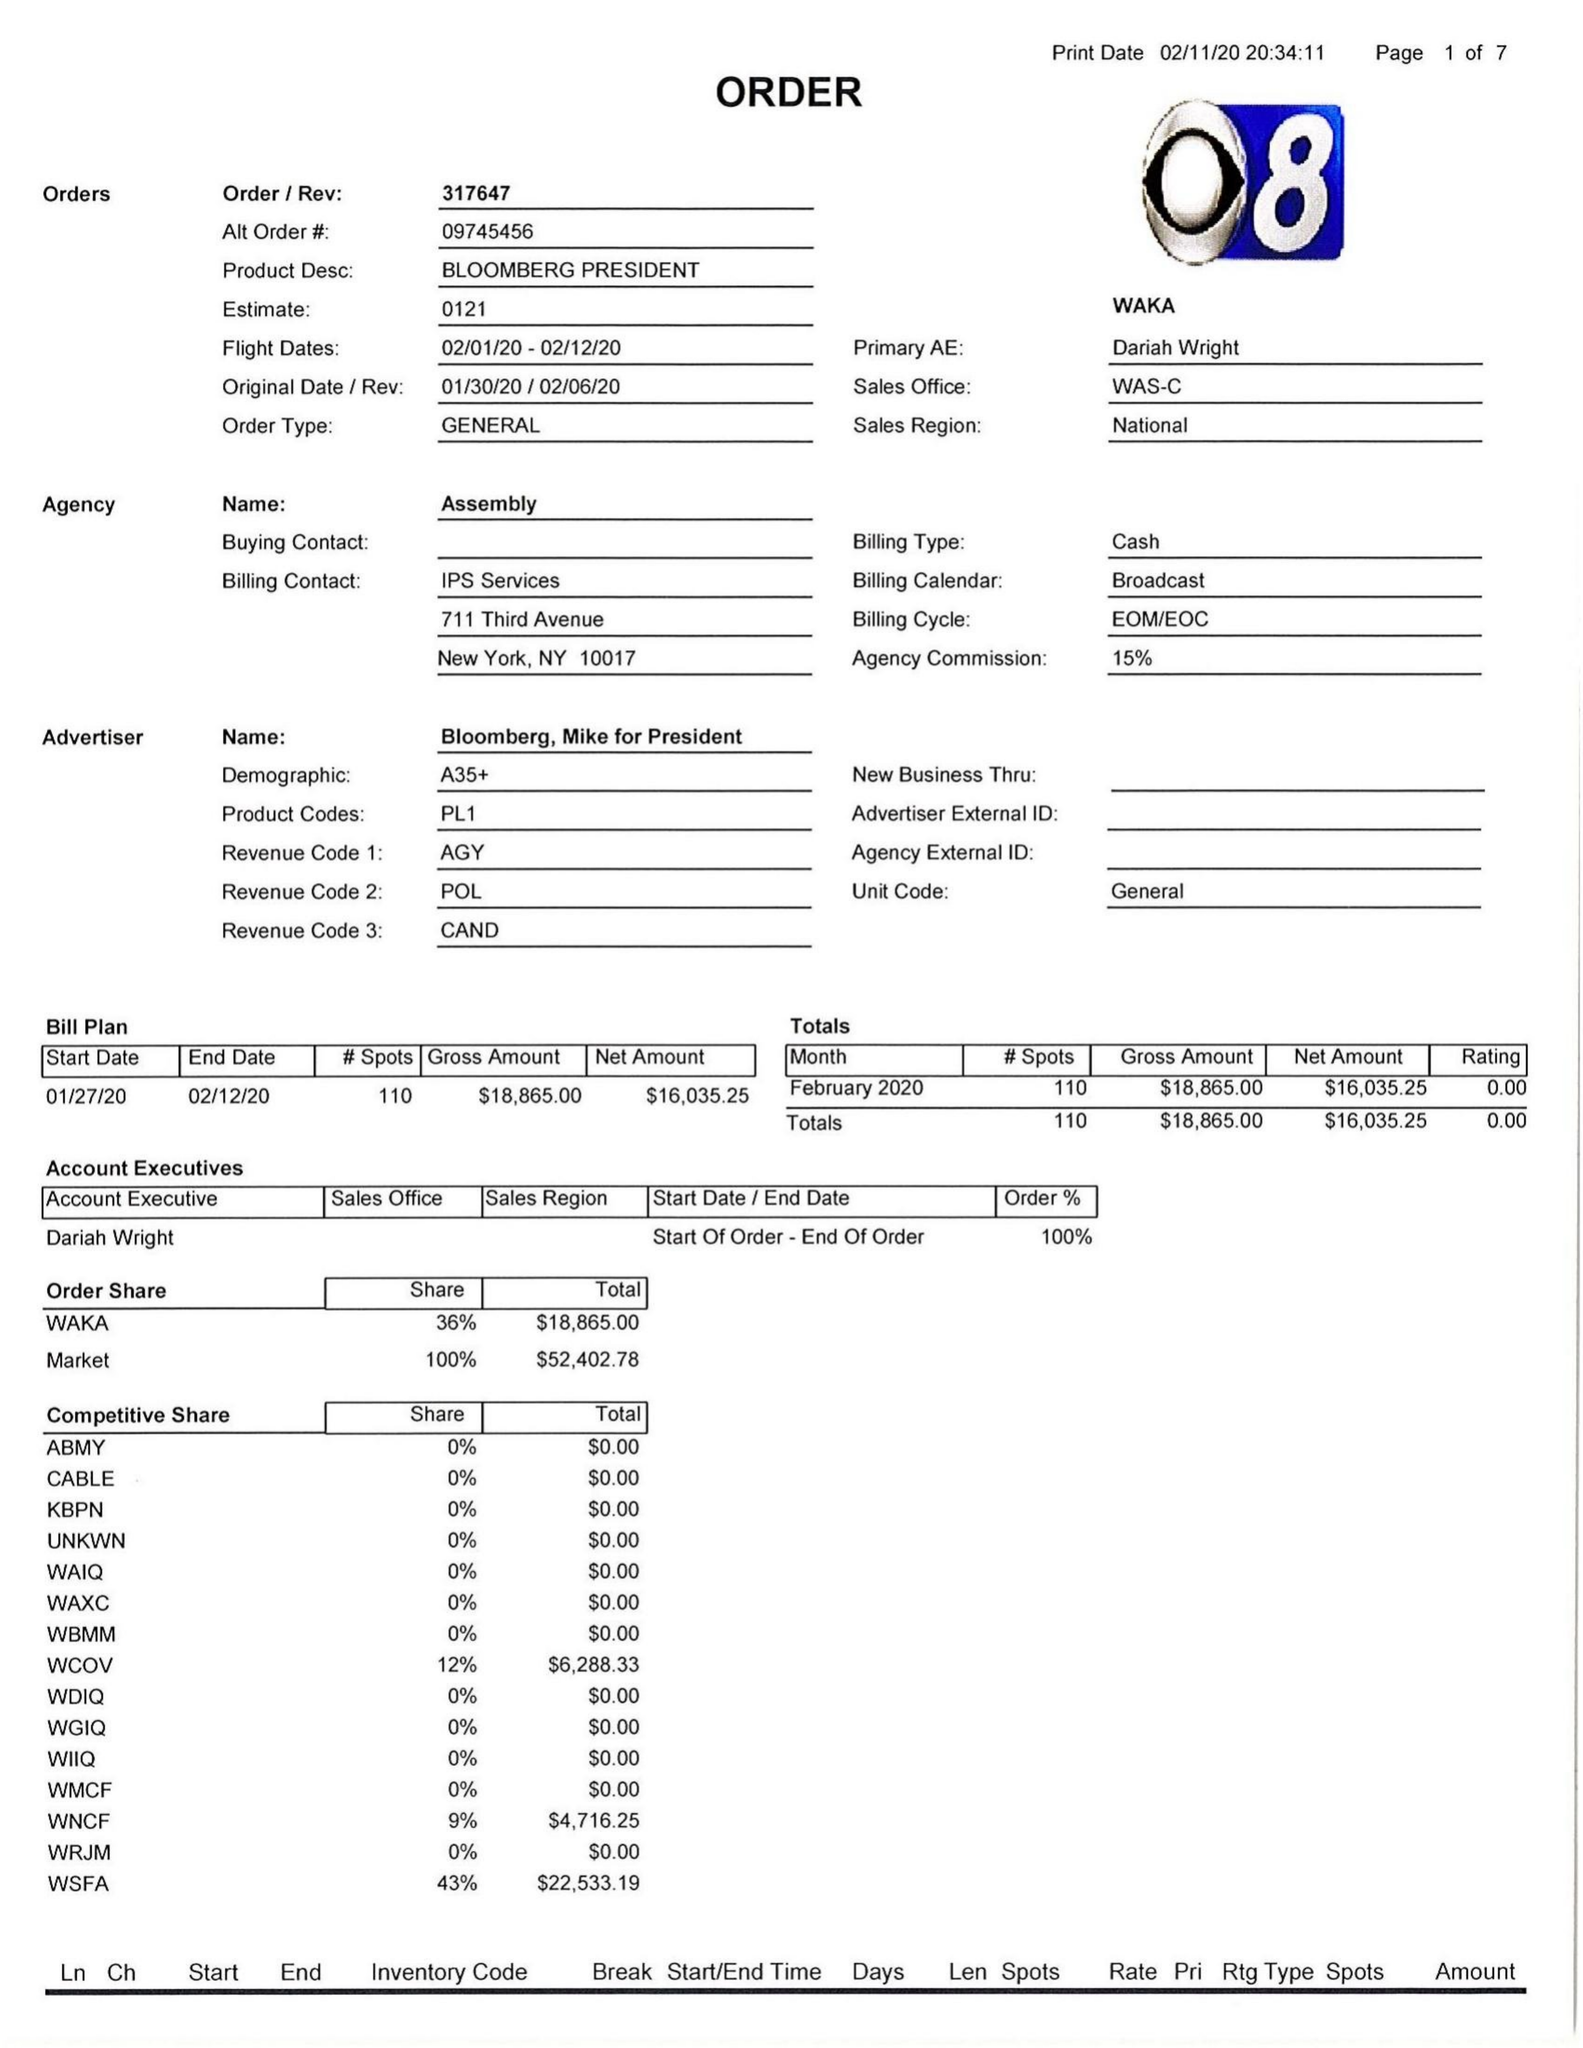What is the value for the gross_amount?
Answer the question using a single word or phrase. 18865.00 